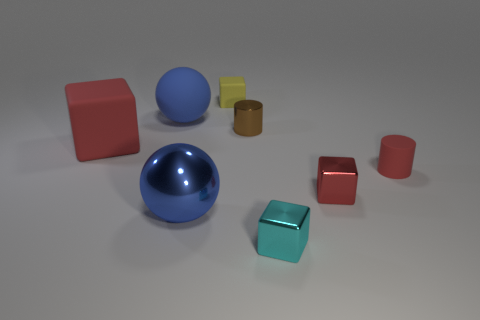Add 1 tiny cyan metal things. How many objects exist? 9 Subtract all balls. How many objects are left? 6 Subtract 0 gray spheres. How many objects are left? 8 Subtract all big blue spheres. Subtract all cyan things. How many objects are left? 5 Add 8 small red rubber cylinders. How many small red rubber cylinders are left? 9 Add 1 yellow metal balls. How many yellow metal balls exist? 1 